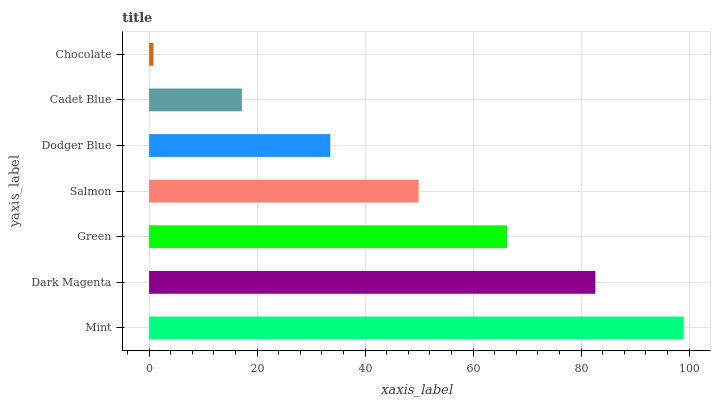Is Chocolate the minimum?
Answer yes or no. Yes. Is Mint the maximum?
Answer yes or no. Yes. Is Dark Magenta the minimum?
Answer yes or no. No. Is Dark Magenta the maximum?
Answer yes or no. No. Is Mint greater than Dark Magenta?
Answer yes or no. Yes. Is Dark Magenta less than Mint?
Answer yes or no. Yes. Is Dark Magenta greater than Mint?
Answer yes or no. No. Is Mint less than Dark Magenta?
Answer yes or no. No. Is Salmon the high median?
Answer yes or no. Yes. Is Salmon the low median?
Answer yes or no. Yes. Is Cadet Blue the high median?
Answer yes or no. No. Is Cadet Blue the low median?
Answer yes or no. No. 